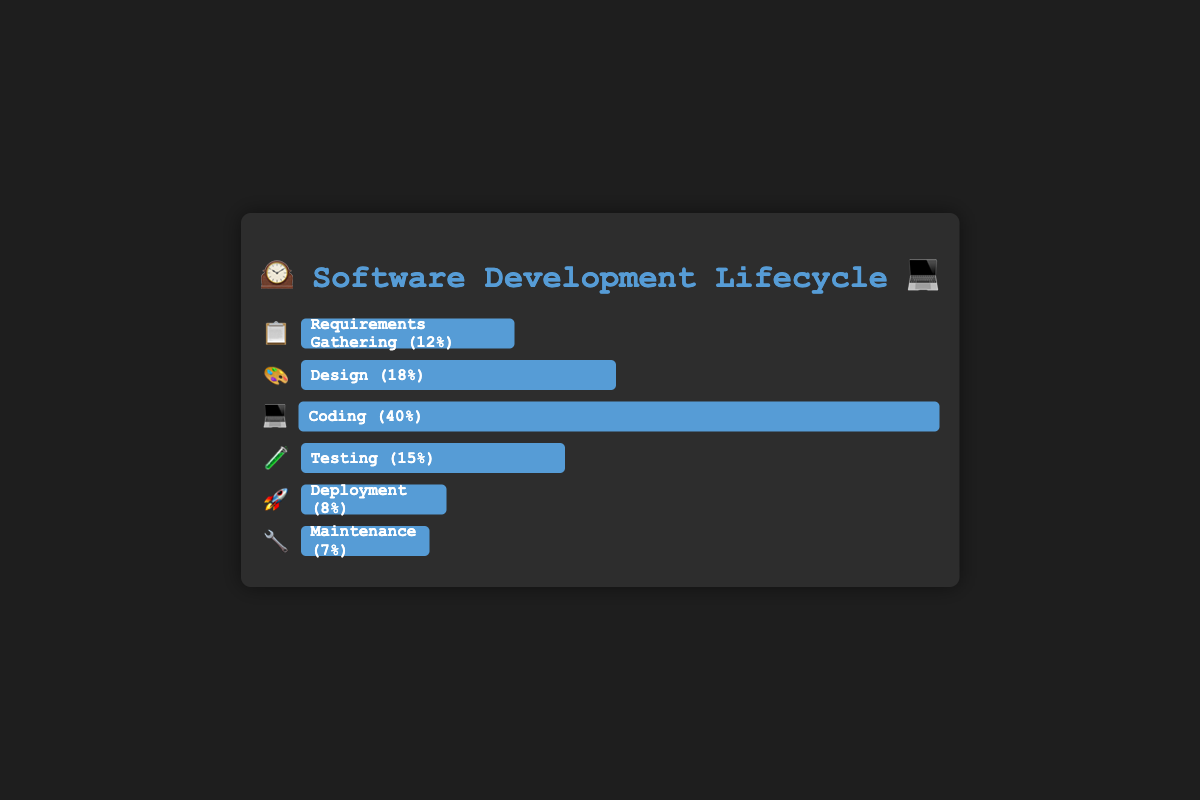What's the title of the figure? The title is usually found at the top of the chart. It provides a summary of what the chart is about. In this case, it appears at the top of the chart container.
Answer: 🕰️ Software Development Lifecycle 💻 Which phase has the maximum time spent? The phase with the maximum time spent will have the longest bar in the chart. By comparing the width of each bar, the "Coding" phase has the longest bar.
Answer: Coding How much time is spent in the Design phase? The time spent on each phase is indicated in the label of each bar. For the Design phase, the label reads "Design (18%)".
Answer: 18% Which phases together take more time than Coding? Coding takes 40% of the time. We need to find phases that together sum to more than 40%. Design (18%), Testing (15%), and Requirements Gathering (12%) together make 45%.
Answer: Design, Testing, Requirements Gathering How much more time is spent on Coding compared to Testing? Subtract the time spent on Testing (15%) from the time spent on Coding (40%). The difference is computed as 40% - 15% = 25%.
Answer: 25% Which phase has the least time spent and how much is it? By looking at the shortest bar in the chart, we see that Maintenance has the least time spent with a label indicating 7%.
Answer: Maintenance, 7% Compare the time spent in Requirements Gathering to Deployment. Which is greater and by how much? Requirements Gathering has 12% and Deployment has 8%. The difference is calculated as 12% - 8% = 4%. Requirements Gathering takes 4% more time than Deployment.
Answer: Requirements Gathering, 4% What is the total percentage of time spent on phases other than Coding? Sum the time spent on all phases except Coding. Requirements Gathering (12%) + Design (18%) + Testing (15%) + Deployment (8%) + Maintenance (7%) = 60%.
Answer: 60% Which phase directly follows Design with the next highest time spent? After Design (18%), look for the next highest value. Testing has 15%, which is the next highest after Design.
Answer: Testing What is the average time spent across all phases? Sum the time spent across all phases: 12% + 18% + 40% + 15% + 8% + 7% = 100%. There are 6 phases, so the average is 100% / 6 = 16.67%.
Answer: 16.67% 